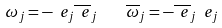Convert formula to latex. <formula><loc_0><loc_0><loc_500><loc_500>\omega _ { j } = - \ e _ { j } \overline { \ e } _ { j } \quad \overline { \omega } _ { j } = - \overline { \ e } _ { j } \ e _ { j }</formula> 